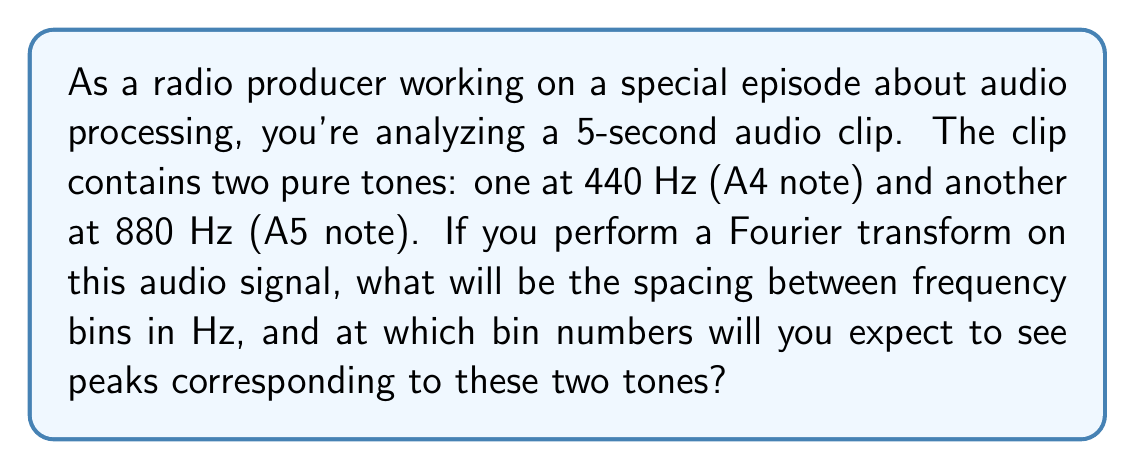Solve this math problem. To solve this problem, we need to understand the relationship between the time domain and frequency domain in the Fourier transform, particularly for discrete signals like digital audio.

1. Frequency Resolution:
   The frequency resolution (spacing between frequency bins) is given by:
   
   $$\Delta f = \frac{f_s}{N}$$
   
   Where $f_s$ is the sampling frequency and $N$ is the number of samples.

2. Sampling Frequency:
   For high-quality audio, we typically use a sampling rate of 44.1 kHz or 48 kHz. Let's assume 48 kHz for this problem.
   
   $$f_s = 48000 \text{ Hz}$$

3. Number of Samples:
   For a 5-second clip at 48 kHz:
   
   $$N = 5 \text{ seconds} \times 48000 \text{ samples/second} = 240000 \text{ samples}$$

4. Calculating Frequency Resolution:
   
   $$\Delta f = \frac{48000 \text{ Hz}}{240000} = 0.2 \text{ Hz}$$

5. Locating Peaks:
   To find the bin numbers for the two tones, we divide their frequencies by the bin spacing:

   For 440 Hz: $\frac{440 \text{ Hz}}{0.2 \text{ Hz/bin}} = 2200$
   For 880 Hz: $\frac{880 \text{ Hz}}{0.2 \text{ Hz/bin}} = 4400$

Therefore, we expect to see peaks at bin numbers 2200 and 4400.
Answer: The frequency resolution (spacing between frequency bins) is 0.2 Hz. The peaks corresponding to the 440 Hz and 880 Hz tones will appear at bin numbers 2200 and 4400, respectively. 